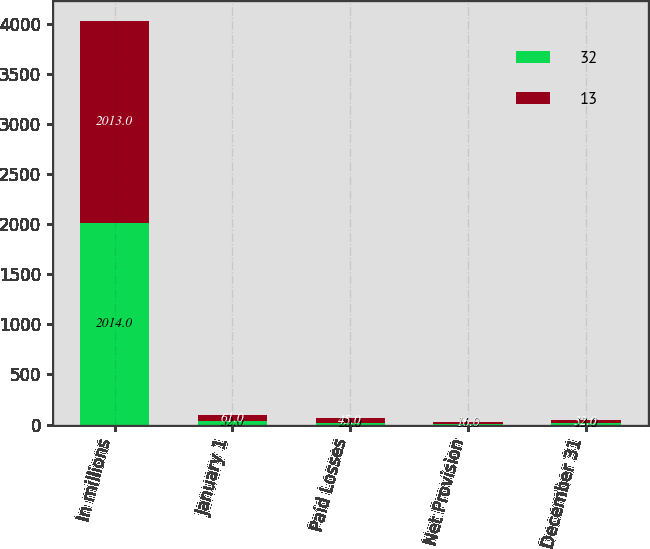Convert chart to OTSL. <chart><loc_0><loc_0><loc_500><loc_500><stacked_bar_chart><ecel><fcel>In millions<fcel>January 1<fcel>Paid Losses<fcel>Net Provision<fcel>December 31<nl><fcel>32<fcel>2014<fcel>32<fcel>20<fcel>11<fcel>13<nl><fcel>13<fcel>2013<fcel>61<fcel>45<fcel>16<fcel>32<nl></chart> 